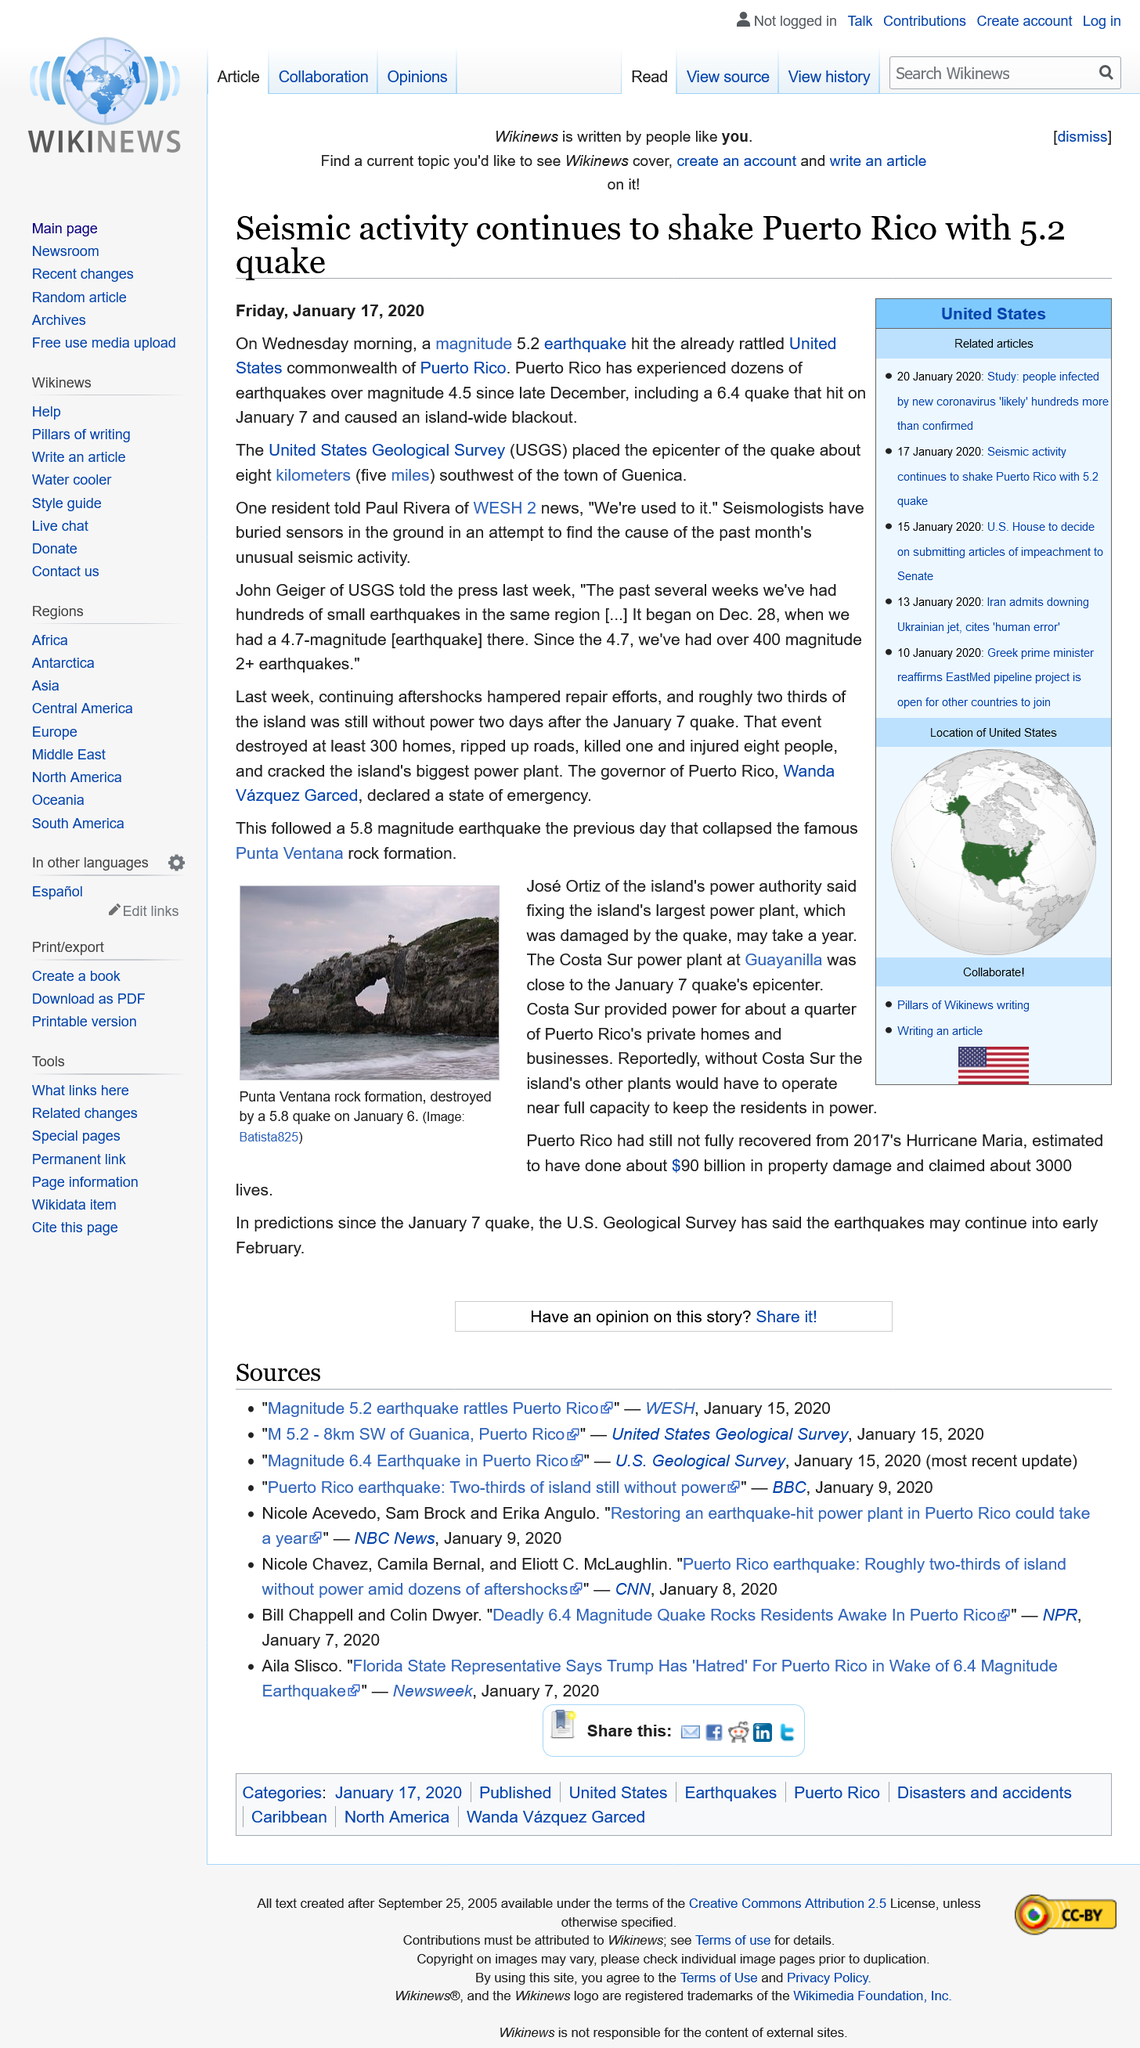Point out several critical features in this image. The epicenter of the earthquake in Puerto Rico on January 15, 2020, was five miles southwest of Guaynabo. On January 15th, 2020, a magnitude 5.2 earthquake hit Puerto Rico. On January 7th, 2020, a 6.4 earthquake hit Puerto Rico, causing a widespread blackout on the island. 